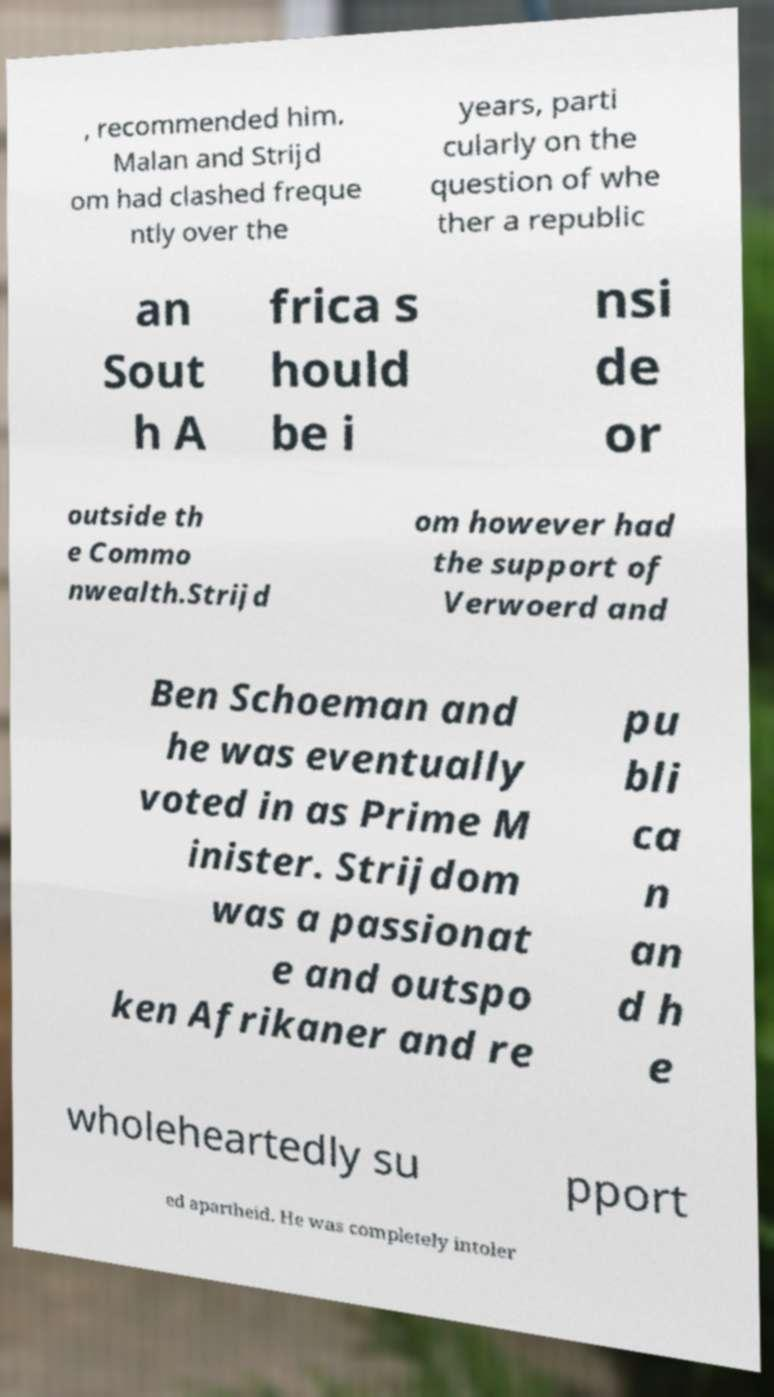There's text embedded in this image that I need extracted. Can you transcribe it verbatim? , recommended him. Malan and Strijd om had clashed freque ntly over the years, parti cularly on the question of whe ther a republic an Sout h A frica s hould be i nsi de or outside th e Commo nwealth.Strijd om however had the support of Verwoerd and Ben Schoeman and he was eventually voted in as Prime M inister. Strijdom was a passionat e and outspo ken Afrikaner and re pu bli ca n an d h e wholeheartedly su pport ed apartheid. He was completely intoler 